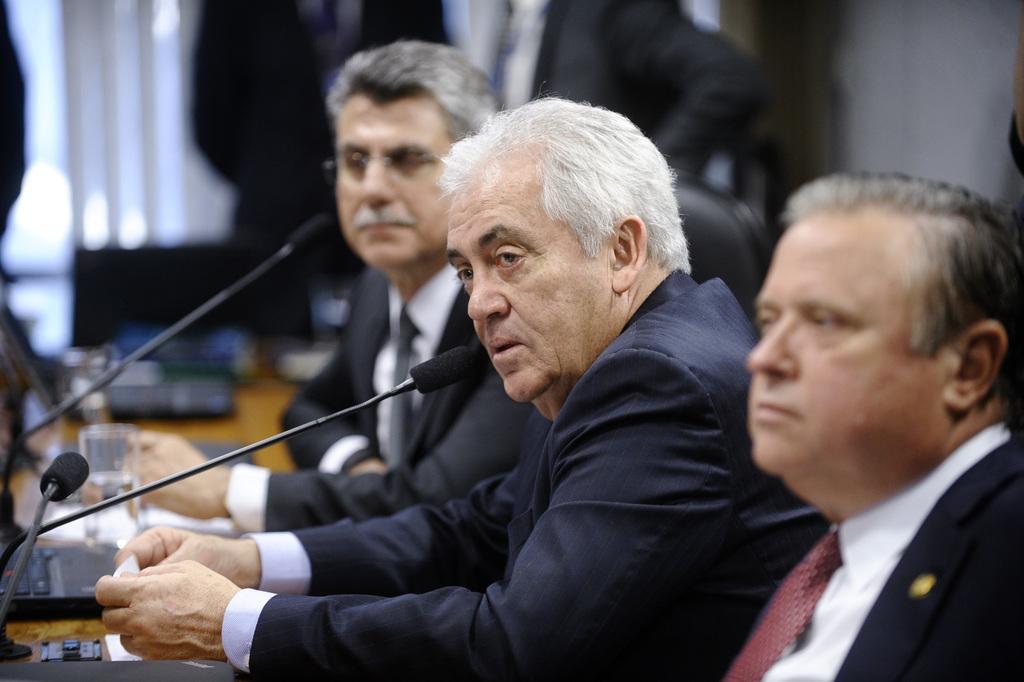How would you summarize this image in a sentence or two? In this picture there are people those who sitting in the center of the image, there sis a table in front of them, on which there is a mix, bottle, and papers on it, there are other people in the background area of the image. 